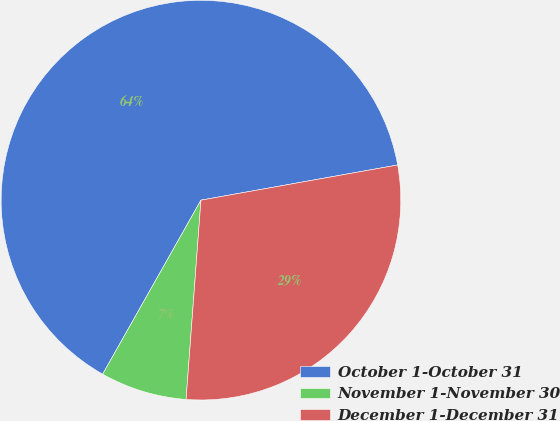<chart> <loc_0><loc_0><loc_500><loc_500><pie_chart><fcel>October 1-October 31<fcel>November 1-November 30<fcel>December 1-December 31<nl><fcel>64.0%<fcel>7.0%<fcel>29.0%<nl></chart> 